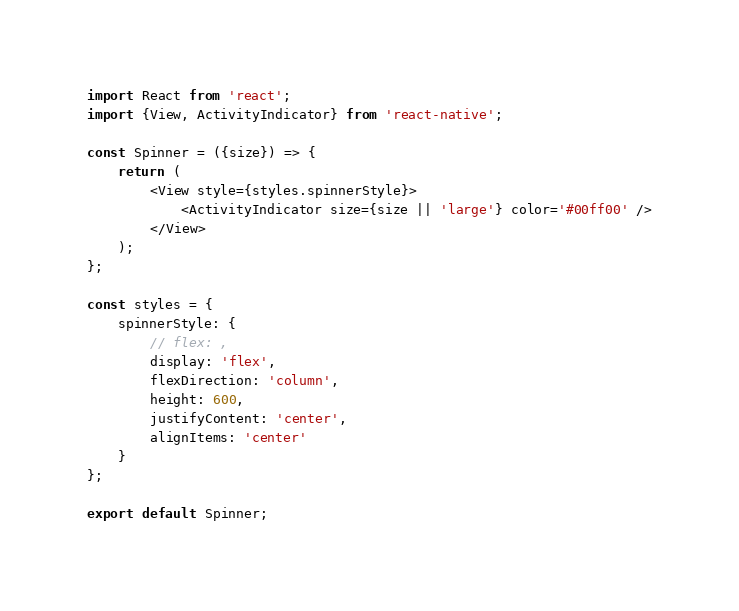<code> <loc_0><loc_0><loc_500><loc_500><_JavaScript_>import React from 'react';
import {View, ActivityIndicator} from 'react-native';

const Spinner = ({size}) => {
    return (
        <View style={styles.spinnerStyle}>
            <ActivityIndicator size={size || 'large'} color='#00ff00' />
        </View>
    );
};

const styles = {
    spinnerStyle: {
        // flex: ,
        display: 'flex',
        flexDirection: 'column',
        height: 600,
        justifyContent: 'center',
        alignItems: 'center'
    }
};

export default Spinner;</code> 